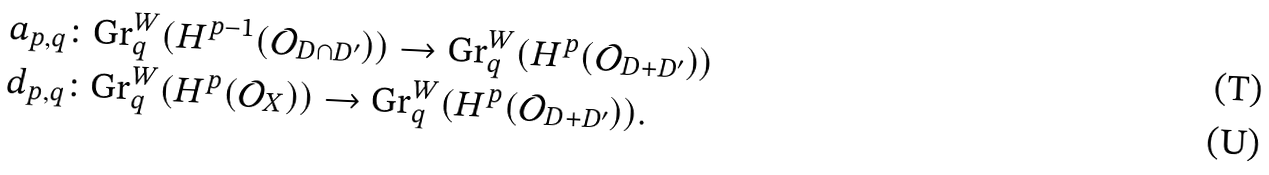Convert formula to latex. <formula><loc_0><loc_0><loc_500><loc_500>& a _ { p , q } \colon \text {Gr} ^ { W } _ { q } ( H ^ { p - 1 } ( \mathcal { O } _ { D \cap D ^ { \prime } } ) ) \to \text {Gr} ^ { W } _ { q } ( H ^ { p } ( \mathcal { O } _ { D + D ^ { \prime } } ) ) \\ & d _ { p , q } \colon \text {Gr} ^ { W } _ { q } ( H ^ { p } ( \mathcal { O } _ { X } ) ) \to \text {Gr} ^ { W } _ { q } ( H ^ { p } ( \mathcal { O } _ { D + D ^ { \prime } } ) ) .</formula> 